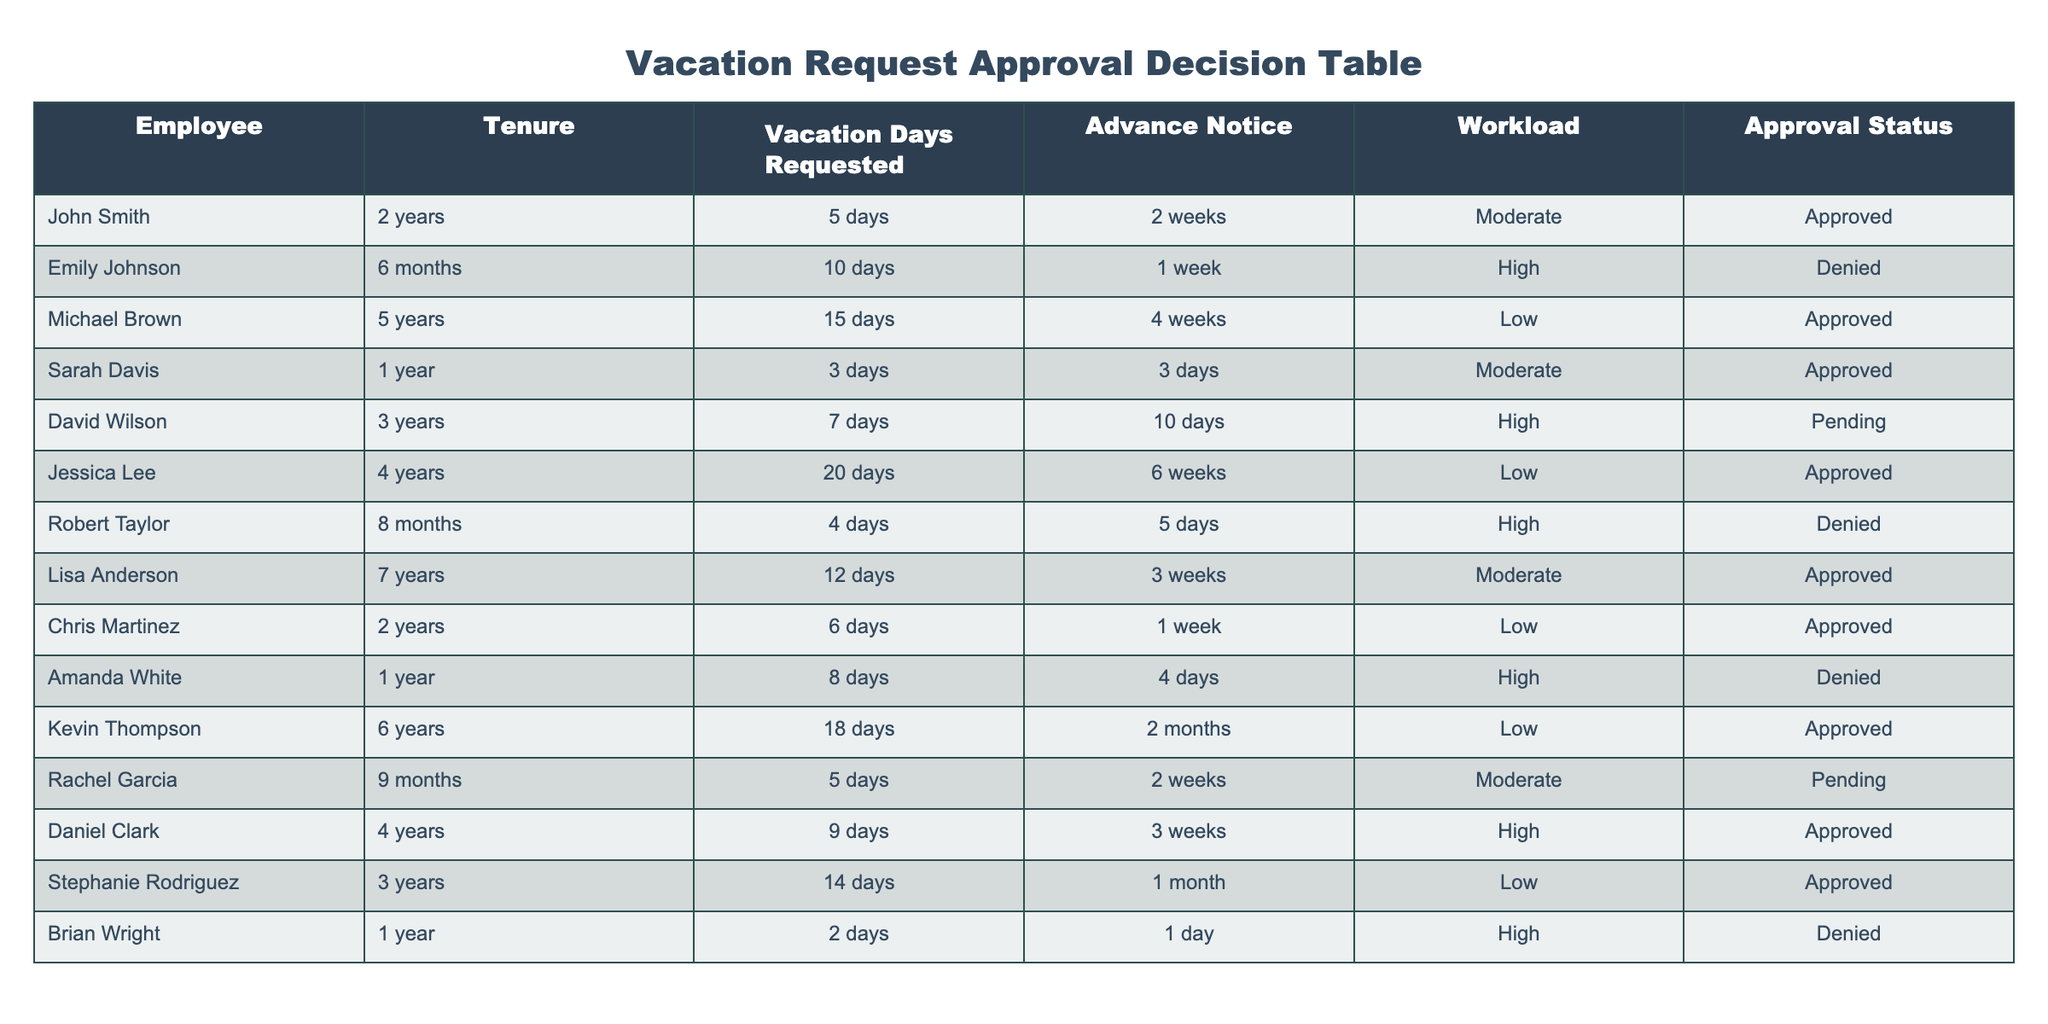What is the approval status of John Smith's vacation request? John Smith's vacation request shows an approval status of "Approved" in the table.
Answer: Approved How many vacation days did Sarah Davis request? According to the table, Sarah Davis requested 3 days of vacation.
Answer: 3 days Which employee has the highest tenure and what is their approval status? The employee with the highest tenure is Jessica Lee with 4 years. Her approval status is "Approved."
Answer: Jessica Lee, Approved Is there any employee who has requested a vacation but their approval status is pending? Yes, there are two employees, David Wilson and Rachel Garcia, who have requested vacations and have a pending approval status.
Answer: Yes What is the average number of vacation days requested by employees with high workload? From the table for high workload employees: Emily Johnson (10 days), Amanda White (8 days), and David Wilson (7 days). The average is (10 + 8 + 7) / 3 = 8.33 days.
Answer: 8.33 days How many employees were denied vacation requests? There are 3 employees who were denied vacation requests: Emily Johnson, Robert Taylor, and Amanda White.
Answer: 3 employees Which employee requested the most vacation days and what was their approval status? Michael Brown requested the most vacation days, totaling 15 days, and his approval status is "Approved."
Answer: Michael Brown, Approved What percentage of requests were approved? There are 9 requests total, with 5 approved. The percentage is (5/9) * 100 ≈ 55.56%.
Answer: 55.56% How many days of advance notice did Chris Martinez provide for his vacation request? Chris Martinez provided 1 week of advance notice for his vacation request, as shown in the table.
Answer: 1 week What is the difference in vacation days requested between the employee with the lowest tenure and the employee with the highest tenure? The employee with the lowest tenure is Robert Taylor with 4 days, and the employee with the highest tenure is Jessica Lee with 20 days. The difference is 20 - 4 = 16 days.
Answer: 16 days 